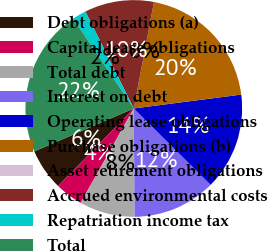<chart> <loc_0><loc_0><loc_500><loc_500><pie_chart><fcel>Debt obligations (a)<fcel>Capital lease obligations<fcel>Total debt<fcel>Interest on debt<fcel>Operating lease obligations<fcel>Purchase obligations (b)<fcel>Asset retirement obligations<fcel>Accrued environmental costs<fcel>Repatriation income tax<fcel>Total<nl><fcel>6.21%<fcel>4.14%<fcel>8.28%<fcel>12.42%<fcel>14.49%<fcel>19.97%<fcel>0.0%<fcel>10.35%<fcel>2.07%<fcel>22.04%<nl></chart> 